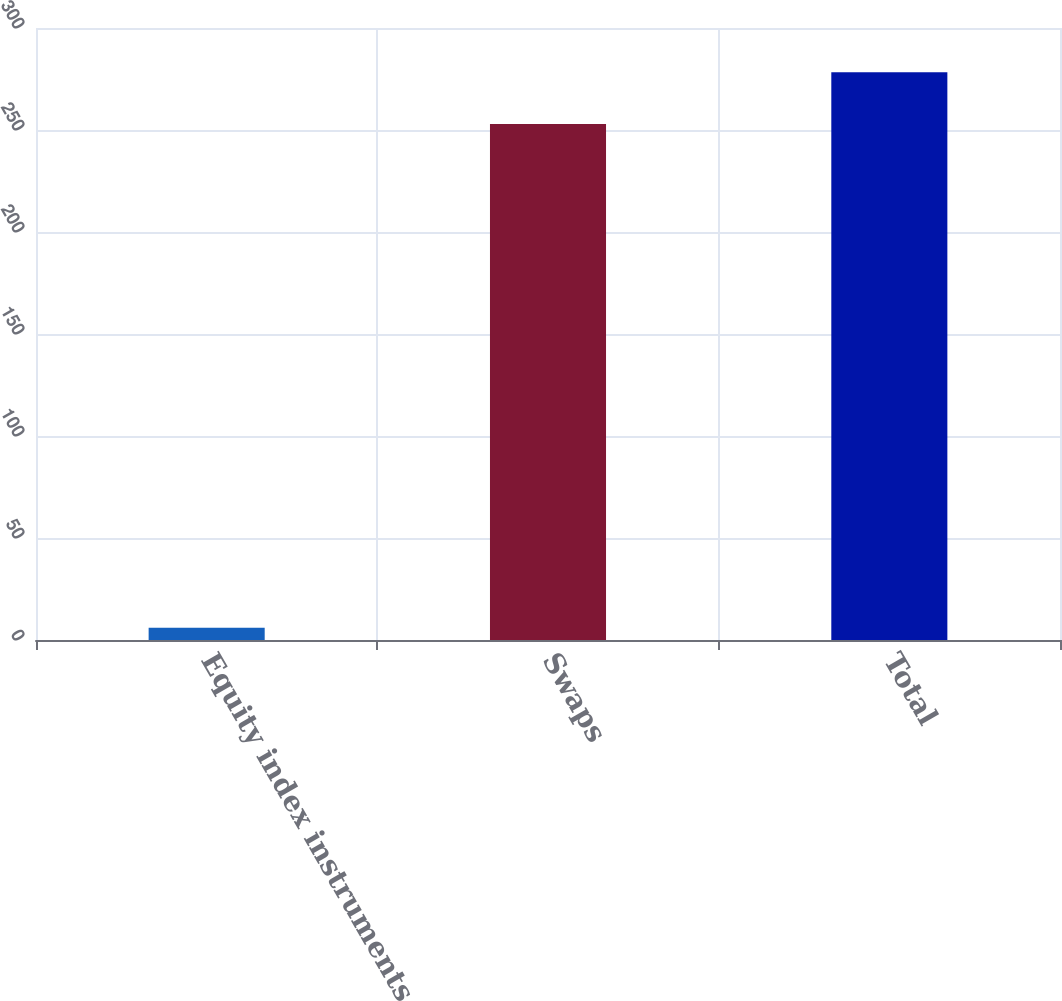<chart> <loc_0><loc_0><loc_500><loc_500><bar_chart><fcel>Equity index instruments<fcel>Swaps<fcel>Total<nl><fcel>6<fcel>253<fcel>278.3<nl></chart> 